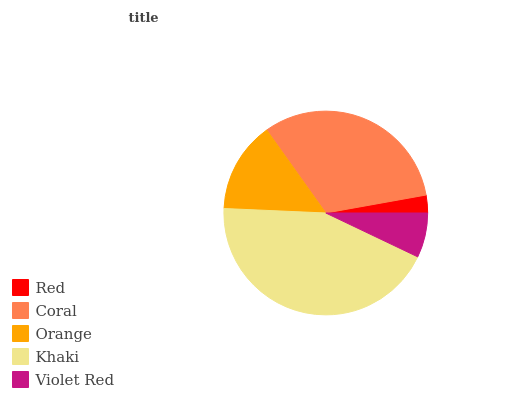Is Red the minimum?
Answer yes or no. Yes. Is Khaki the maximum?
Answer yes or no. Yes. Is Coral the minimum?
Answer yes or no. No. Is Coral the maximum?
Answer yes or no. No. Is Coral greater than Red?
Answer yes or no. Yes. Is Red less than Coral?
Answer yes or no. Yes. Is Red greater than Coral?
Answer yes or no. No. Is Coral less than Red?
Answer yes or no. No. Is Orange the high median?
Answer yes or no. Yes. Is Orange the low median?
Answer yes or no. Yes. Is Coral the high median?
Answer yes or no. No. Is Coral the low median?
Answer yes or no. No. 